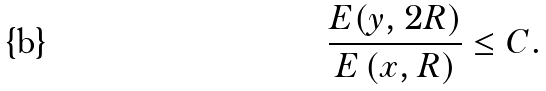<formula> <loc_0><loc_0><loc_500><loc_500>\frac { E ( y , 2 R ) } { E \left ( x , R \right ) } \leq C .</formula> 